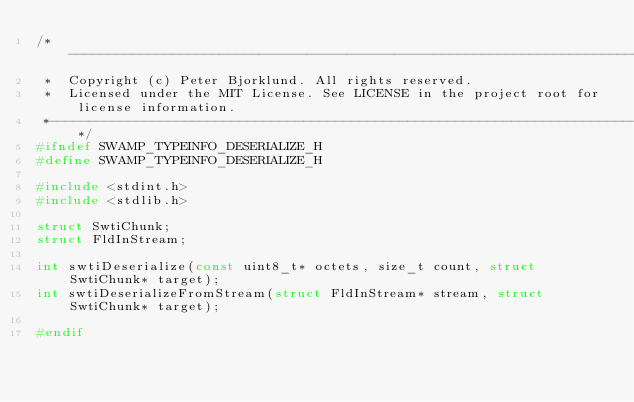Convert code to text. <code><loc_0><loc_0><loc_500><loc_500><_C_>/*---------------------------------------------------------------------------------------------
 *  Copyright (c) Peter Bjorklund. All rights reserved.
 *  Licensed under the MIT License. See LICENSE in the project root for license information.
 *--------------------------------------------------------------------------------------------*/
#ifndef SWAMP_TYPEINFO_DESERIALIZE_H
#define SWAMP_TYPEINFO_DESERIALIZE_H

#include <stdint.h>
#include <stdlib.h>

struct SwtiChunk;
struct FldInStream;

int swtiDeserialize(const uint8_t* octets, size_t count, struct SwtiChunk* target);
int swtiDeserializeFromStream(struct FldInStream* stream, struct SwtiChunk* target);

#endif
</code> 